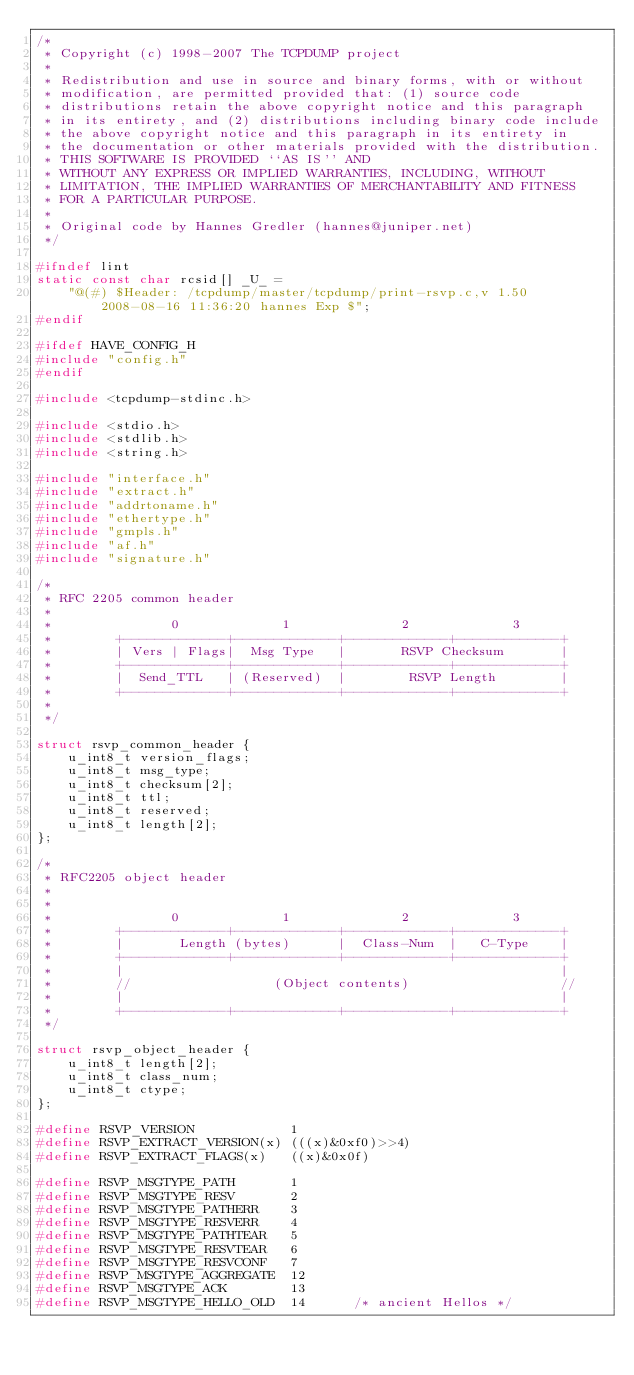Convert code to text. <code><loc_0><loc_0><loc_500><loc_500><_C_>/*
 * Copyright (c) 1998-2007 The TCPDUMP project
 *
 * Redistribution and use in source and binary forms, with or without
 * modification, are permitted provided that: (1) source code
 * distributions retain the above copyright notice and this paragraph
 * in its entirety, and (2) distributions including binary code include
 * the above copyright notice and this paragraph in its entirety in
 * the documentation or other materials provided with the distribution.
 * THIS SOFTWARE IS PROVIDED ``AS IS'' AND
 * WITHOUT ANY EXPRESS OR IMPLIED WARRANTIES, INCLUDING, WITHOUT
 * LIMITATION, THE IMPLIED WARRANTIES OF MERCHANTABILITY AND FITNESS
 * FOR A PARTICULAR PURPOSE.
 *
 * Original code by Hannes Gredler (hannes@juniper.net)
 */

#ifndef lint
static const char rcsid[] _U_ =
    "@(#) $Header: /tcpdump/master/tcpdump/print-rsvp.c,v 1.50 2008-08-16 11:36:20 hannes Exp $";
#endif

#ifdef HAVE_CONFIG_H
#include "config.h"
#endif

#include <tcpdump-stdinc.h>

#include <stdio.h>
#include <stdlib.h>
#include <string.h>

#include "interface.h"
#include "extract.h"
#include "addrtoname.h"
#include "ethertype.h"
#include "gmpls.h"
#include "af.h"
#include "signature.h"

/*
 * RFC 2205 common header
 *
 *               0             1              2             3
 *        +-------------+-------------+-------------+-------------+
 *        | Vers | Flags|  Msg Type   |       RSVP Checksum       |
 *        +-------------+-------------+-------------+-------------+
 *        |  Send_TTL   | (Reserved)  |        RSVP Length        |
 *        +-------------+-------------+-------------+-------------+
 *
 */

struct rsvp_common_header {
    u_int8_t version_flags;
    u_int8_t msg_type;
    u_int8_t checksum[2];
    u_int8_t ttl;
    u_int8_t reserved;
    u_int8_t length[2];
};

/* 
 * RFC2205 object header
 *
 * 
 *               0             1              2             3
 *        +-------------+-------------+-------------+-------------+
 *        |       Length (bytes)      |  Class-Num  |   C-Type    |
 *        +-------------+-------------+-------------+-------------+
 *        |                                                       |
 *        //                  (Object contents)                   //
 *        |                                                       |
 *        +-------------+-------------+-------------+-------------+
 */

struct rsvp_object_header {
    u_int8_t length[2];
    u_int8_t class_num;
    u_int8_t ctype;
};

#define RSVP_VERSION            1
#define	RSVP_EXTRACT_VERSION(x) (((x)&0xf0)>>4) 
#define	RSVP_EXTRACT_FLAGS(x)   ((x)&0x0f)

#define	RSVP_MSGTYPE_PATH       1
#define	RSVP_MSGTYPE_RESV       2
#define	RSVP_MSGTYPE_PATHERR    3
#define	RSVP_MSGTYPE_RESVERR    4
#define	RSVP_MSGTYPE_PATHTEAR   5
#define	RSVP_MSGTYPE_RESVTEAR   6
#define	RSVP_MSGTYPE_RESVCONF   7
#define RSVP_MSGTYPE_AGGREGATE  12
#define RSVP_MSGTYPE_ACK        13
#define RSVP_MSGTYPE_HELLO_OLD  14      /* ancient Hellos */</code> 